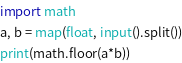Convert code to text. <code><loc_0><loc_0><loc_500><loc_500><_Python_>import math
a, b = map(float, input().split())
print(math.floor(a*b))</code> 